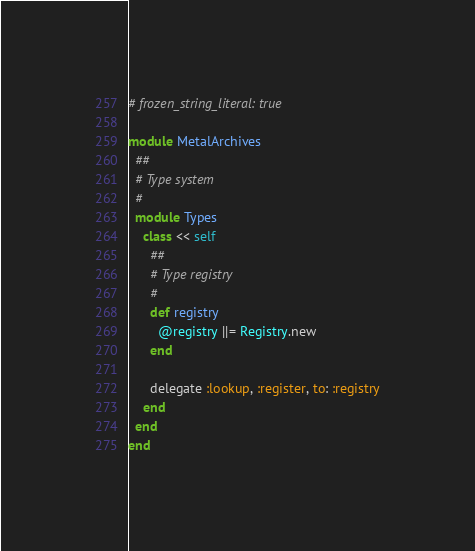<code> <loc_0><loc_0><loc_500><loc_500><_Ruby_># frozen_string_literal: true

module MetalArchives
  ##
  # Type system
  #
  module Types
    class << self
      ##
      # Type registry
      #
      def registry
        @registry ||= Registry.new
      end

      delegate :lookup, :register, to: :registry
    end
  end
end
</code> 